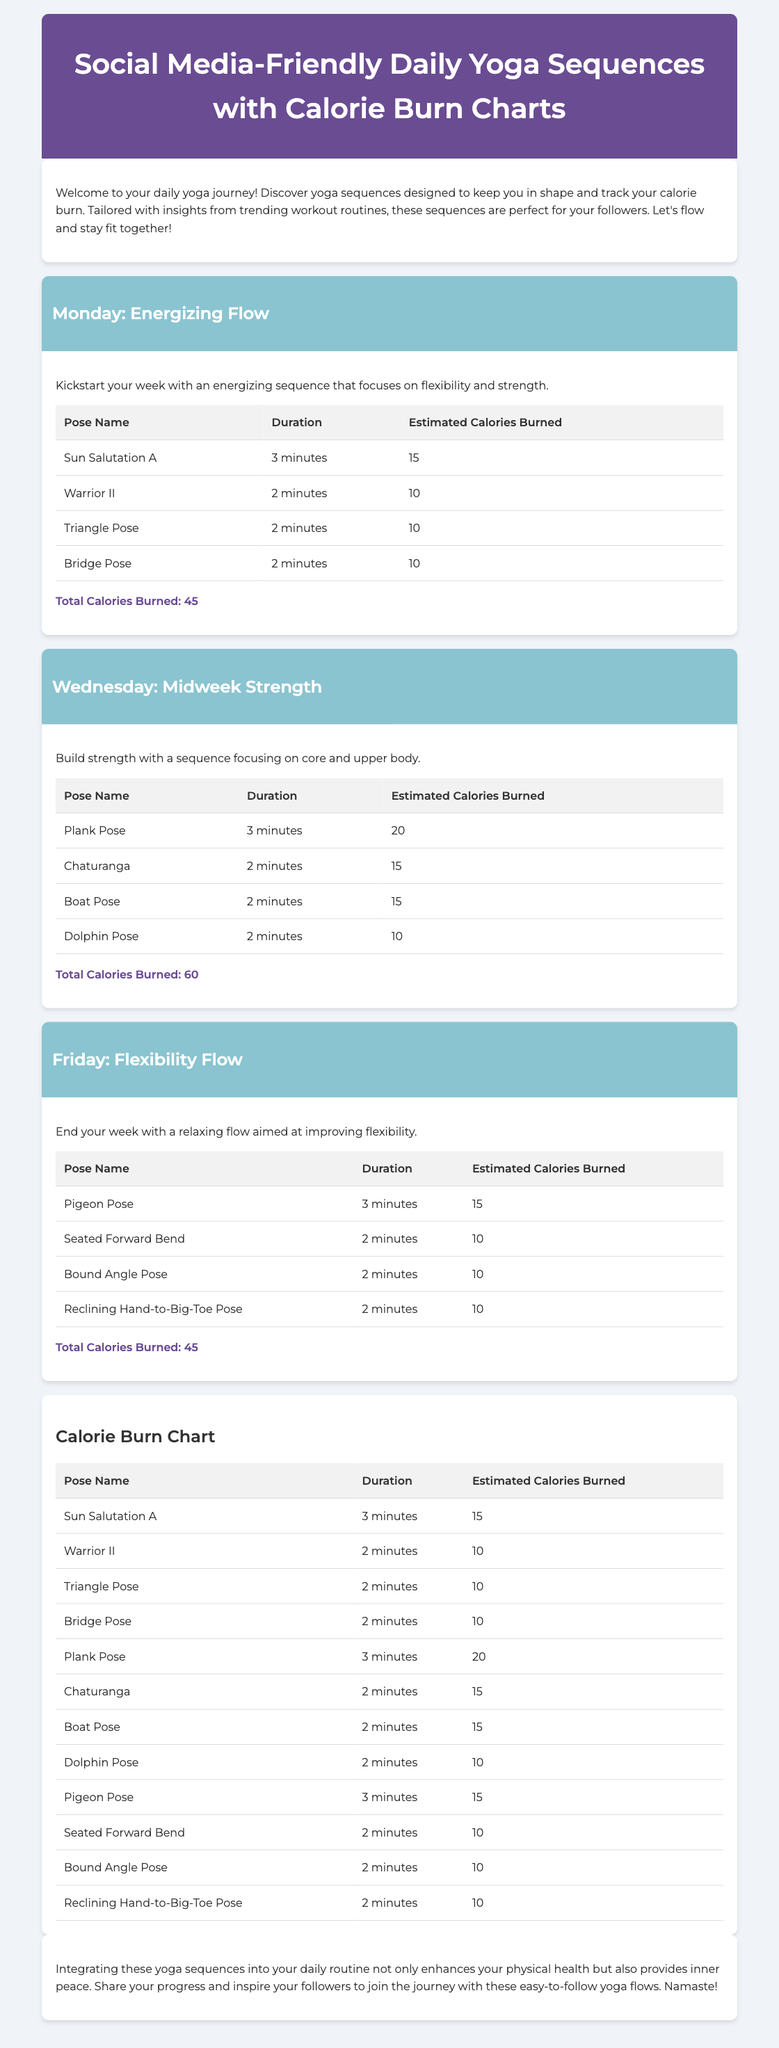What is the title of the document? The title appears in the header section of the document and is "Social Media-Friendly Daily Yoga Sequences with Calorie Burn Charts."
Answer: Social Media-Friendly Daily Yoga Sequences with Calorie Burn Charts What is the total calorie burn for Wednesday's sequence? The total calories burned for Wednesday's sequence is mentioned under the sequence, which is 60.
Answer: 60 What is the pose that burns the most calories on Monday? The pose with the highest calorie burn on Monday is listed in the table, which shows Plank Pose.
Answer: Sun Salutation A How many poses are included in the Friday sequence? The number of poses can be counted from the corresponding table for Friday, which lists four poses.
Answer: 4 What duration is assigned to the Pigeon Pose? The duration for Pigeon Pose is found in its table row, which states that it is held for 3 minutes.
Answer: 3 minutes What day of the week is represented by the sequence titled "Flexibility Flow"? The title clearly indicates the day assigned to the Flexibility Flow as Friday through its header.
Answer: Friday Which pose appears twice in the Calorie Burn Chart? The calorie chart repeats poses based on their occurrences, and the pose "Sun Salutation A" appears in the chart.
Answer: Sun Salutation A What is the estimated calorie burn for the Dolphin Pose? The estimated calorie burn is specified in detail in the corresponding row for the Dolphin Pose in the tables, which identifies it as 10 calories.
Answer: 10 